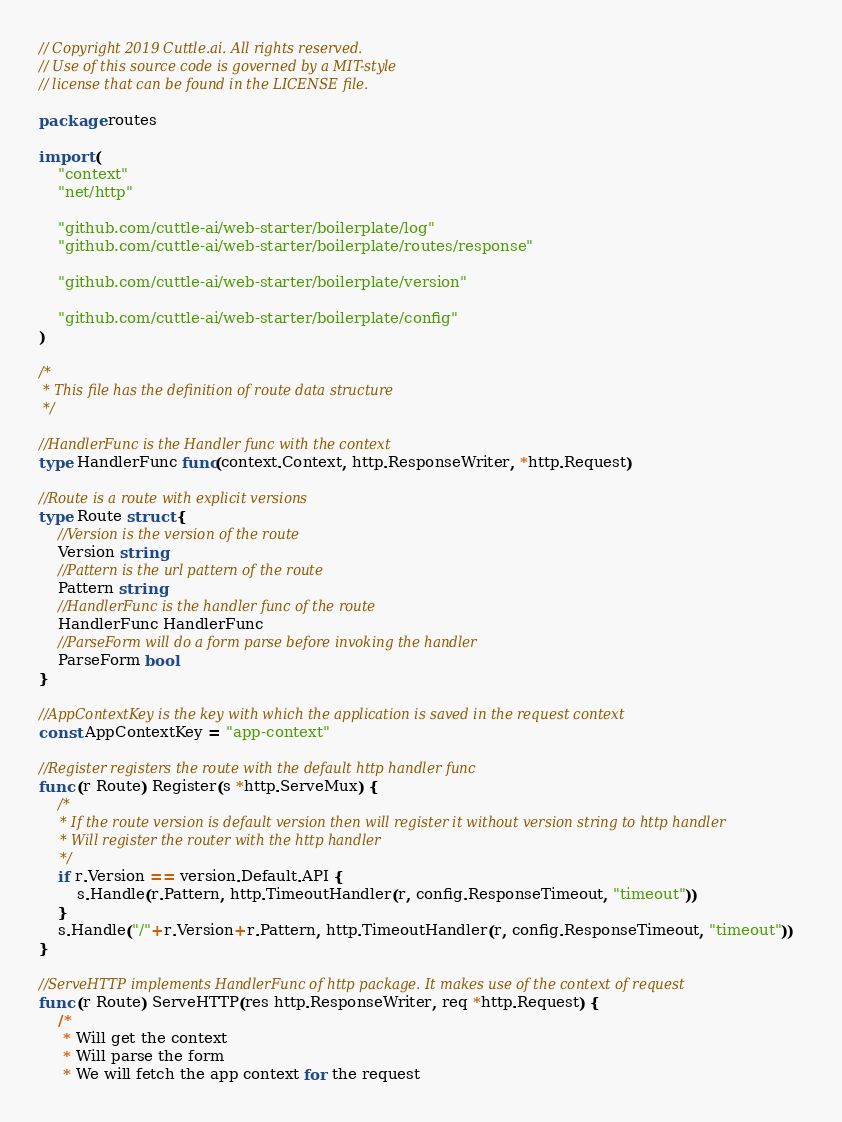Convert code to text. <code><loc_0><loc_0><loc_500><loc_500><_Go_>// Copyright 2019 Cuttle.ai. All rights reserved.
// Use of this source code is governed by a MIT-style
// license that can be found in the LICENSE file.

package routes

import (
	"context"
	"net/http"

	"github.com/cuttle-ai/web-starter/boilerplate/log"
	"github.com/cuttle-ai/web-starter/boilerplate/routes/response"

	"github.com/cuttle-ai/web-starter/boilerplate/version"

	"github.com/cuttle-ai/web-starter/boilerplate/config"
)

/*
 * This file has the definition of route data structure
 */

//HandlerFunc is the Handler func with the context
type HandlerFunc func(context.Context, http.ResponseWriter, *http.Request)

//Route is a route with explicit versions
type Route struct {
	//Version is the version of the route
	Version string
	//Pattern is the url pattern of the route
	Pattern string
	//HandlerFunc is the handler func of the route
	HandlerFunc HandlerFunc
	//ParseForm will do a form parse before invoking the handler
	ParseForm bool
}

//AppContextKey is the key with which the application is saved in the request context
const AppContextKey = "app-context"

//Register registers the route with the default http handler func
func (r Route) Register(s *http.ServeMux) {
	/*
	 * If the route version is default version then will register it without version string to http handler
	 * Will register the router with the http handler
	 */
	if r.Version == version.Default.API {
		s.Handle(r.Pattern, http.TimeoutHandler(r, config.ResponseTimeout, "timeout"))
	}
	s.Handle("/"+r.Version+r.Pattern, http.TimeoutHandler(r, config.ResponseTimeout, "timeout"))
}

//ServeHTTP implements HandlerFunc of http package. It makes use of the context of request
func (r Route) ServeHTTP(res http.ResponseWriter, req *http.Request) {
	/*
	 * Will get the context
	 * Will parse the form
	 * We will fetch the app context for the request</code> 